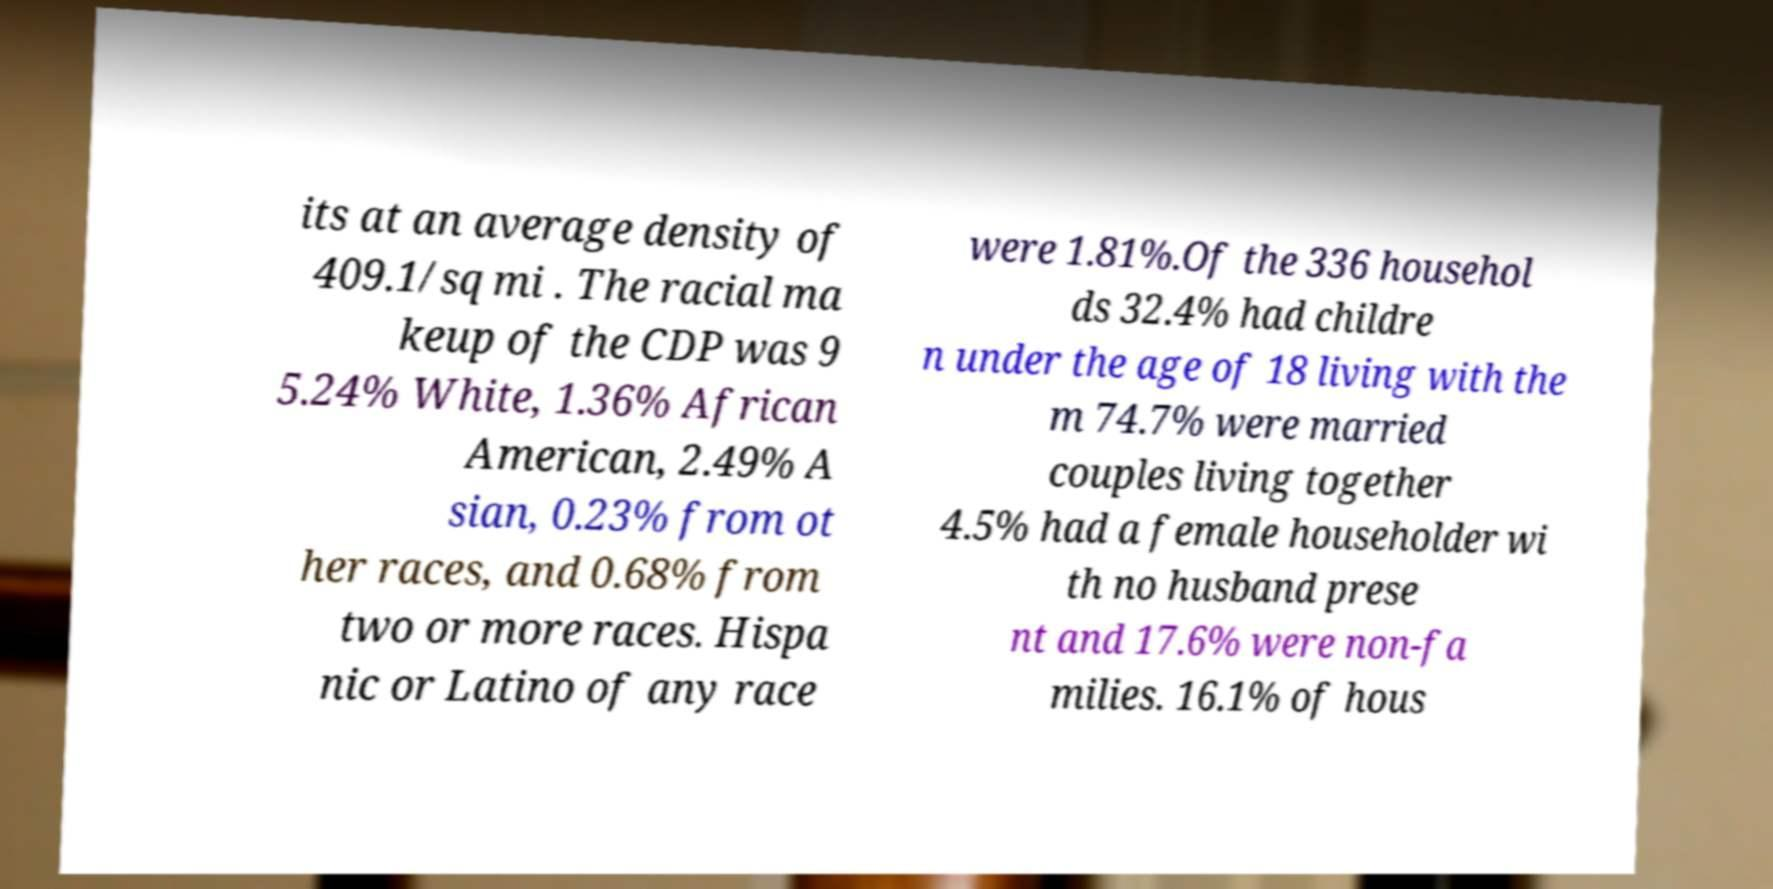I need the written content from this picture converted into text. Can you do that? its at an average density of 409.1/sq mi . The racial ma keup of the CDP was 9 5.24% White, 1.36% African American, 2.49% A sian, 0.23% from ot her races, and 0.68% from two or more races. Hispa nic or Latino of any race were 1.81%.Of the 336 househol ds 32.4% had childre n under the age of 18 living with the m 74.7% were married couples living together 4.5% had a female householder wi th no husband prese nt and 17.6% were non-fa milies. 16.1% of hous 